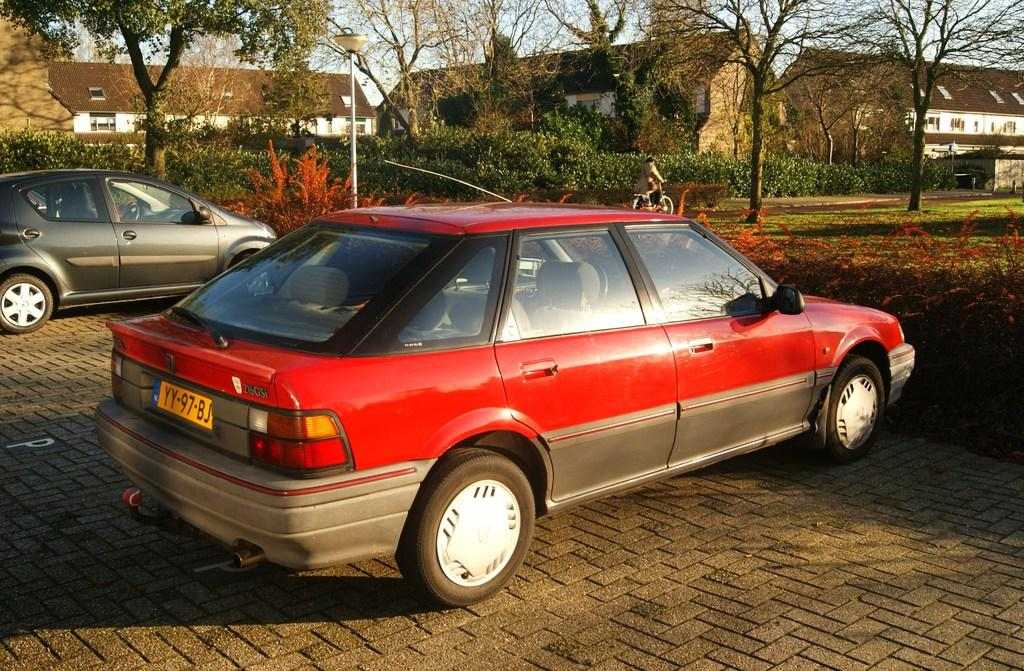How many cars are parked in the image? There are two cars parked in the image. What mode of transportation is being used by the person in the image? The person is riding a bicycle a bicycle in the image. What can be seen in the background of the image? There are trees, plants, a pole, buildings, and the sky visible in the background of the image. What type of glue is being used to hold the bicycle together in the image? There is no indication in the image that the bicycle is being held together with glue, and therefore no such activity can be observed. 